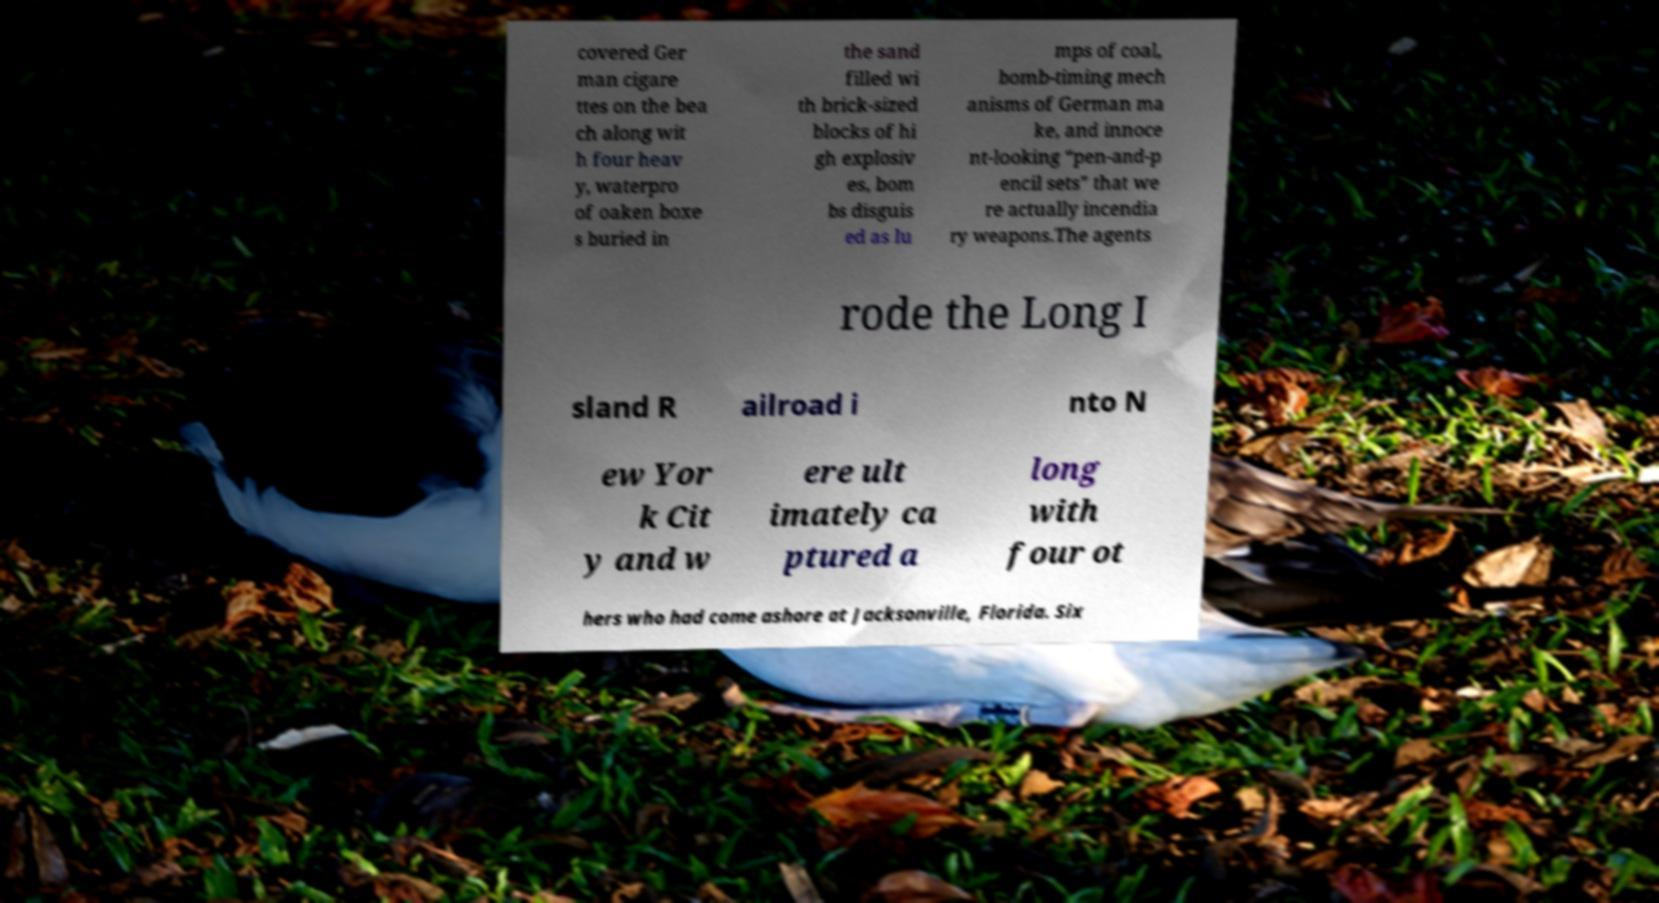Please read and relay the text visible in this image. What does it say? covered Ger man cigare ttes on the bea ch along wit h four heav y, waterpro of oaken boxe s buried in the sand filled wi th brick-sized blocks of hi gh explosiv es, bom bs disguis ed as lu mps of coal, bomb-timing mech anisms of German ma ke, and innoce nt-looking “pen-and-p encil sets” that we re actually incendia ry weapons.The agents rode the Long I sland R ailroad i nto N ew Yor k Cit y and w ere ult imately ca ptured a long with four ot hers who had come ashore at Jacksonville, Florida. Six 